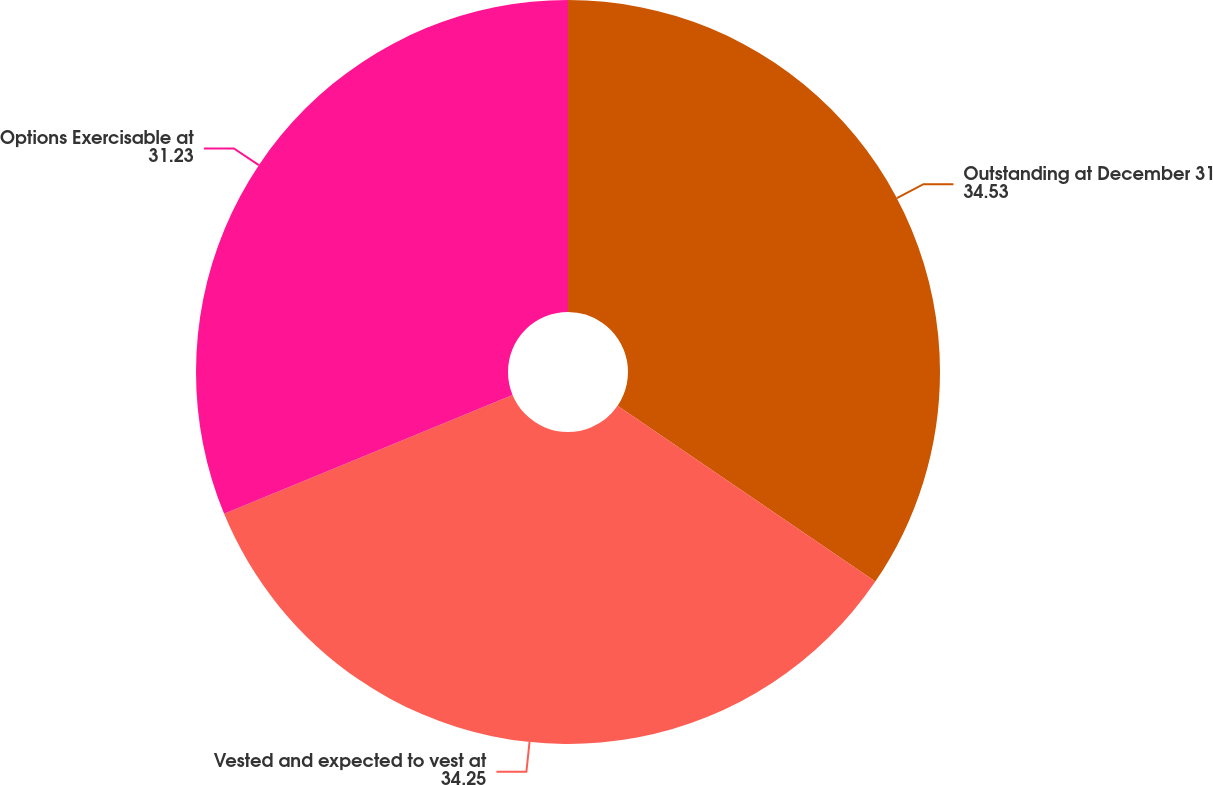<chart> <loc_0><loc_0><loc_500><loc_500><pie_chart><fcel>Outstanding at December 31<fcel>Vested and expected to vest at<fcel>Options Exercisable at<nl><fcel>34.53%<fcel>34.25%<fcel>31.23%<nl></chart> 